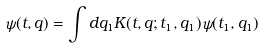Convert formula to latex. <formula><loc_0><loc_0><loc_500><loc_500>\psi ( t , q ) = \int d q _ { 1 } K ( t , q ; t _ { 1 } , q _ { 1 } ) \psi ( t _ { 1 } , q _ { 1 } )</formula> 